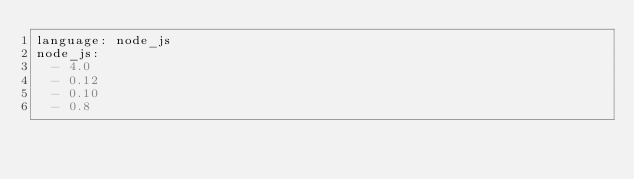<code> <loc_0><loc_0><loc_500><loc_500><_YAML_>language: node_js
node_js:
  - 4.0
  - 0.12
  - 0.10
  - 0.8
</code> 